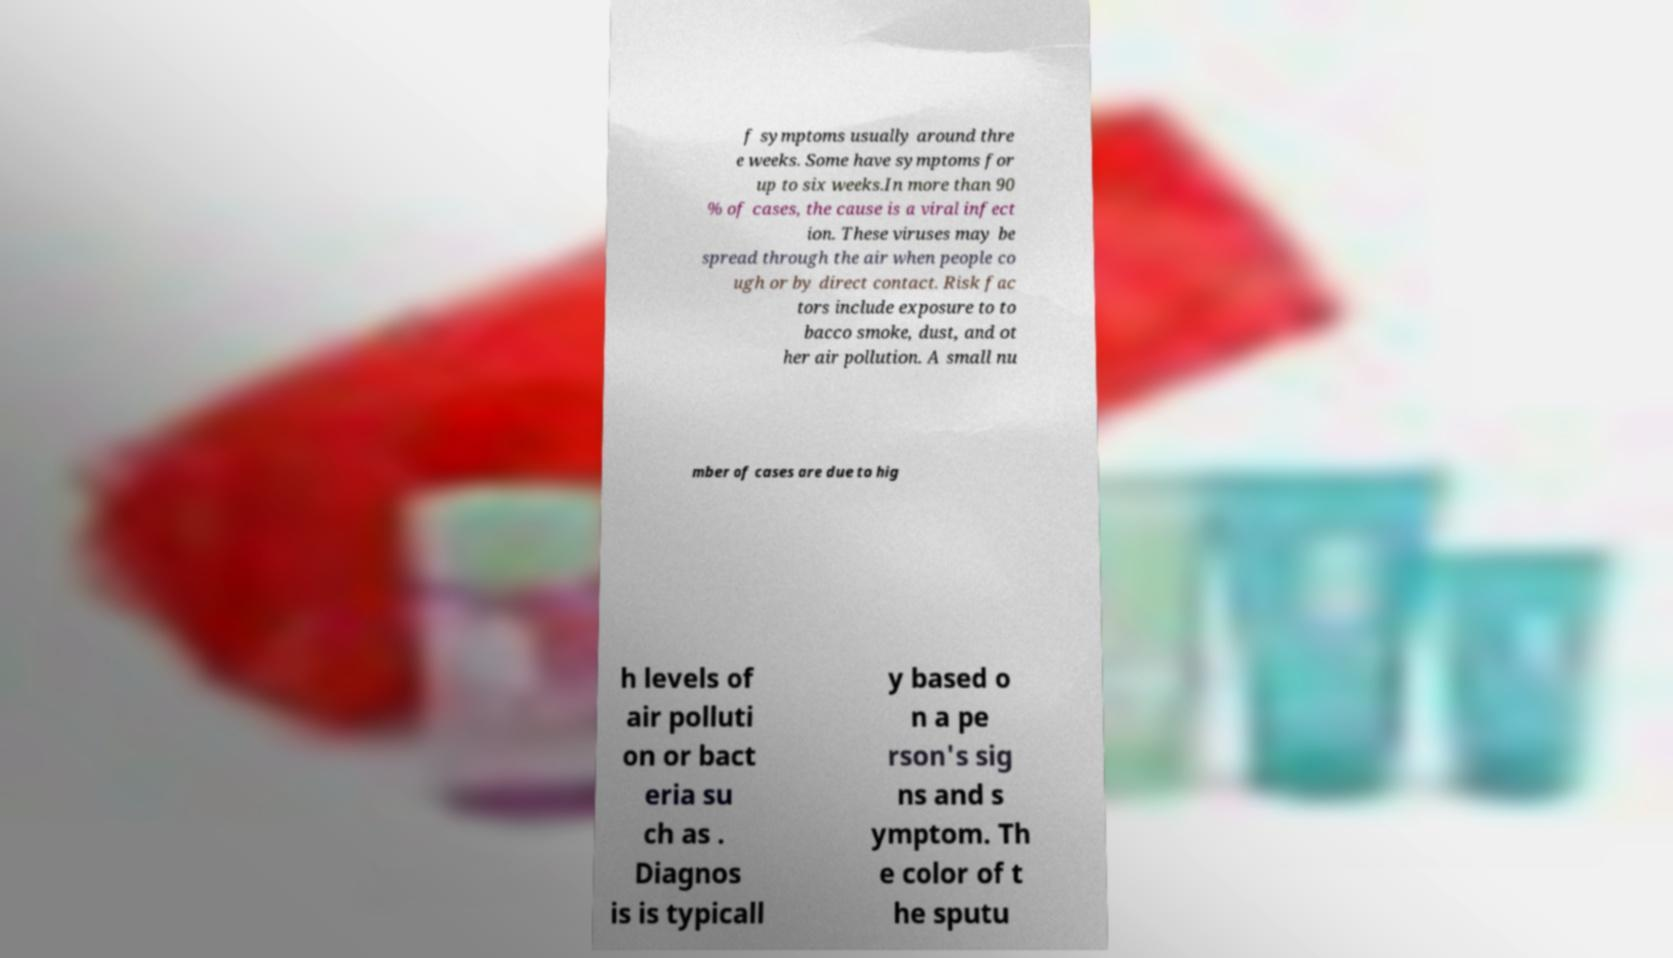There's text embedded in this image that I need extracted. Can you transcribe it verbatim? f symptoms usually around thre e weeks. Some have symptoms for up to six weeks.In more than 90 % of cases, the cause is a viral infect ion. These viruses may be spread through the air when people co ugh or by direct contact. Risk fac tors include exposure to to bacco smoke, dust, and ot her air pollution. A small nu mber of cases are due to hig h levels of air polluti on or bact eria su ch as . Diagnos is is typicall y based o n a pe rson's sig ns and s ymptom. Th e color of t he sputu 